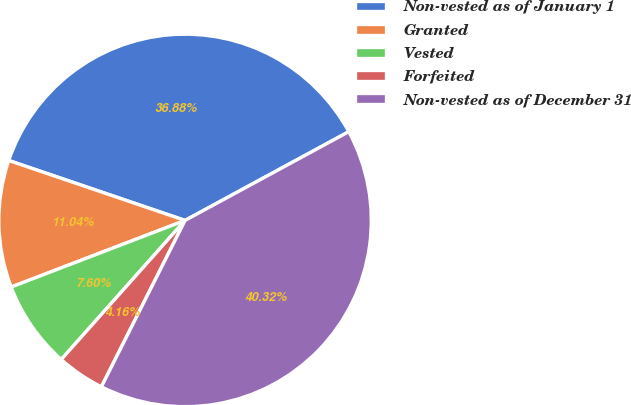Convert chart to OTSL. <chart><loc_0><loc_0><loc_500><loc_500><pie_chart><fcel>Non-vested as of January 1<fcel>Granted<fcel>Vested<fcel>Forfeited<fcel>Non-vested as of December 31<nl><fcel>36.88%<fcel>11.04%<fcel>7.6%<fcel>4.16%<fcel>40.32%<nl></chart> 